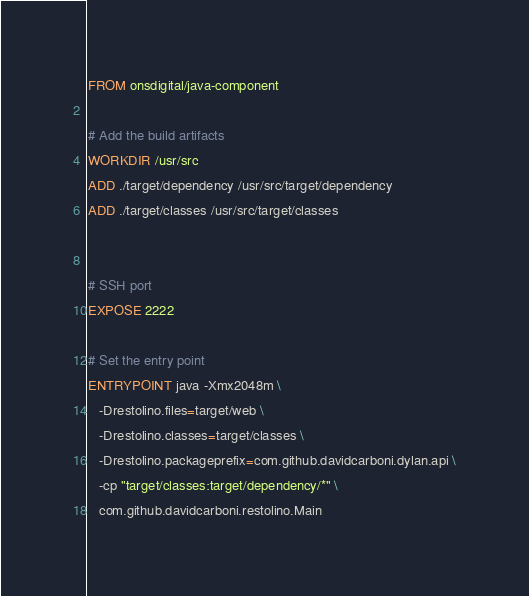<code> <loc_0><loc_0><loc_500><loc_500><_Dockerfile_>FROM onsdigital/java-component

# Add the build artifacts
WORKDIR /usr/src
ADD ./target/dependency /usr/src/target/dependency
ADD ./target/classes /usr/src/target/classes


# SSH port
EXPOSE 2222

# Set the entry point
ENTRYPOINT java -Xmx2048m \
   -Drestolino.files=target/web \
   -Drestolino.classes=target/classes \
   -Drestolino.packageprefix=com.github.davidcarboni.dylan.api \
   -cp "target/classes:target/dependency/*" \
   com.github.davidcarboni.restolino.Main
</code> 